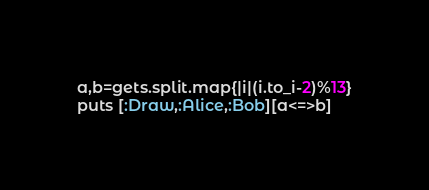<code> <loc_0><loc_0><loc_500><loc_500><_Ruby_>a,b=gets.split.map{|i|(i.to_i-2)%13}
puts [:Draw,:Alice,:Bob][a<=>b]</code> 